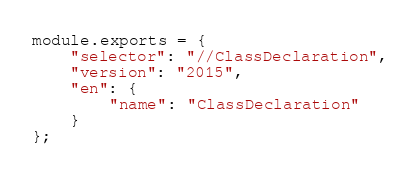<code> <loc_0><loc_0><loc_500><loc_500><_JavaScript_>module.exports = {
    "selector": "//ClassDeclaration",
    "version": "2015",
    "en": {
        "name": "ClassDeclaration"
    }
};</code> 